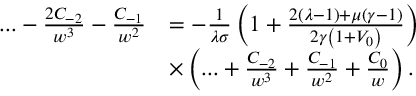<formula> <loc_0><loc_0><loc_500><loc_500>\begin{array} { r l } { \dots - \frac { 2 C _ { - 2 } } { w ^ { 3 } } - \frac { C _ { - 1 } } { w ^ { 2 } } } & { = - \frac { 1 } { \lambda \sigma } \left ( 1 + \frac { 2 \left ( \lambda - 1 \right ) + \mu \left ( \gamma - 1 \right ) } { 2 \gamma \left ( 1 + V _ { 0 } \right ) } \right ) } \\ & { \times \left ( \dots + \frac { C _ { - 2 } } { w ^ { 3 } } + \frac { C _ { - 1 } } { w ^ { 2 } } + \frac { C _ { 0 } } { w } \right ) . } \end{array}</formula> 